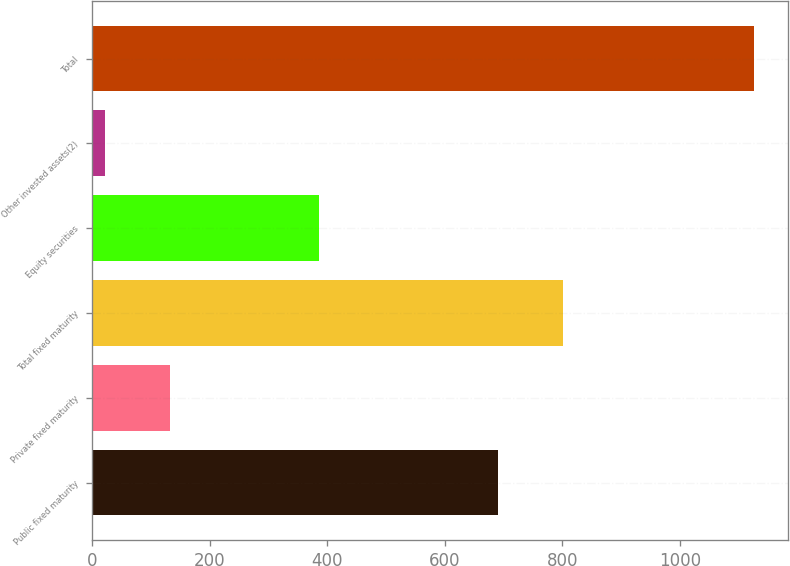<chart> <loc_0><loc_0><loc_500><loc_500><bar_chart><fcel>Public fixed maturity<fcel>Private fixed maturity<fcel>Total fixed maturity<fcel>Equity securities<fcel>Other invested assets(2)<fcel>Total<nl><fcel>690<fcel>132.5<fcel>800.5<fcel>387<fcel>22<fcel>1127<nl></chart> 